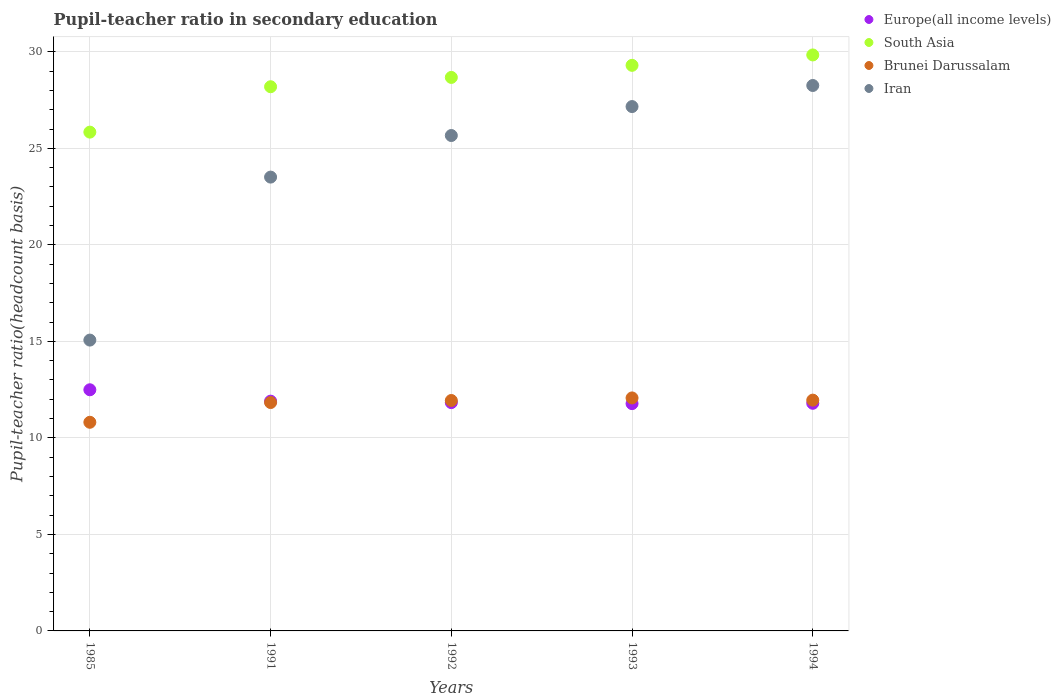What is the pupil-teacher ratio in secondary education in Brunei Darussalam in 1992?
Offer a terse response. 11.94. Across all years, what is the maximum pupil-teacher ratio in secondary education in South Asia?
Offer a very short reply. 29.84. Across all years, what is the minimum pupil-teacher ratio in secondary education in Brunei Darussalam?
Your answer should be compact. 10.81. What is the total pupil-teacher ratio in secondary education in Europe(all income levels) in the graph?
Give a very brief answer. 59.79. What is the difference between the pupil-teacher ratio in secondary education in South Asia in 1991 and that in 1994?
Provide a succinct answer. -1.65. What is the difference between the pupil-teacher ratio in secondary education in South Asia in 1985 and the pupil-teacher ratio in secondary education in Iran in 1993?
Provide a succinct answer. -1.32. What is the average pupil-teacher ratio in secondary education in Iran per year?
Provide a succinct answer. 23.93. In the year 1985, what is the difference between the pupil-teacher ratio in secondary education in Iran and pupil-teacher ratio in secondary education in Europe(all income levels)?
Your response must be concise. 2.57. What is the ratio of the pupil-teacher ratio in secondary education in Brunei Darussalam in 1991 to that in 1994?
Keep it short and to the point. 0.99. Is the pupil-teacher ratio in secondary education in Europe(all income levels) in 1985 less than that in 1992?
Give a very brief answer. No. Is the difference between the pupil-teacher ratio in secondary education in Iran in 1992 and 1993 greater than the difference between the pupil-teacher ratio in secondary education in Europe(all income levels) in 1992 and 1993?
Offer a very short reply. No. What is the difference between the highest and the second highest pupil-teacher ratio in secondary education in Brunei Darussalam?
Your response must be concise. 0.11. What is the difference between the highest and the lowest pupil-teacher ratio in secondary education in Europe(all income levels)?
Provide a succinct answer. 0.72. In how many years, is the pupil-teacher ratio in secondary education in Europe(all income levels) greater than the average pupil-teacher ratio in secondary education in Europe(all income levels) taken over all years?
Ensure brevity in your answer.  1. Is it the case that in every year, the sum of the pupil-teacher ratio in secondary education in Europe(all income levels) and pupil-teacher ratio in secondary education in Iran  is greater than the sum of pupil-teacher ratio in secondary education in South Asia and pupil-teacher ratio in secondary education in Brunei Darussalam?
Provide a short and direct response. Yes. Is it the case that in every year, the sum of the pupil-teacher ratio in secondary education in Europe(all income levels) and pupil-teacher ratio in secondary education in Iran  is greater than the pupil-teacher ratio in secondary education in South Asia?
Make the answer very short. Yes. Is the pupil-teacher ratio in secondary education in Iran strictly greater than the pupil-teacher ratio in secondary education in Brunei Darussalam over the years?
Make the answer very short. Yes. Is the pupil-teacher ratio in secondary education in Iran strictly less than the pupil-teacher ratio in secondary education in Brunei Darussalam over the years?
Your response must be concise. No. How many dotlines are there?
Your answer should be compact. 4. How many years are there in the graph?
Give a very brief answer. 5. Are the values on the major ticks of Y-axis written in scientific E-notation?
Give a very brief answer. No. Does the graph contain any zero values?
Offer a very short reply. No. Where does the legend appear in the graph?
Your answer should be very brief. Top right. What is the title of the graph?
Provide a short and direct response. Pupil-teacher ratio in secondary education. Does "St. Lucia" appear as one of the legend labels in the graph?
Your response must be concise. No. What is the label or title of the X-axis?
Your response must be concise. Years. What is the label or title of the Y-axis?
Provide a short and direct response. Pupil-teacher ratio(headcount basis). What is the Pupil-teacher ratio(headcount basis) of Europe(all income levels) in 1985?
Offer a terse response. 12.49. What is the Pupil-teacher ratio(headcount basis) in South Asia in 1985?
Give a very brief answer. 25.84. What is the Pupil-teacher ratio(headcount basis) in Brunei Darussalam in 1985?
Provide a succinct answer. 10.81. What is the Pupil-teacher ratio(headcount basis) of Iran in 1985?
Provide a short and direct response. 15.07. What is the Pupil-teacher ratio(headcount basis) in Europe(all income levels) in 1991?
Your response must be concise. 11.9. What is the Pupil-teacher ratio(headcount basis) in South Asia in 1991?
Make the answer very short. 28.19. What is the Pupil-teacher ratio(headcount basis) in Brunei Darussalam in 1991?
Your response must be concise. 11.83. What is the Pupil-teacher ratio(headcount basis) of Iran in 1991?
Make the answer very short. 23.51. What is the Pupil-teacher ratio(headcount basis) of Europe(all income levels) in 1992?
Your response must be concise. 11.83. What is the Pupil-teacher ratio(headcount basis) of South Asia in 1992?
Keep it short and to the point. 28.68. What is the Pupil-teacher ratio(headcount basis) in Brunei Darussalam in 1992?
Keep it short and to the point. 11.94. What is the Pupil-teacher ratio(headcount basis) of Iran in 1992?
Offer a terse response. 25.67. What is the Pupil-teacher ratio(headcount basis) of Europe(all income levels) in 1993?
Offer a terse response. 11.78. What is the Pupil-teacher ratio(headcount basis) in South Asia in 1993?
Provide a short and direct response. 29.3. What is the Pupil-teacher ratio(headcount basis) in Brunei Darussalam in 1993?
Offer a very short reply. 12.07. What is the Pupil-teacher ratio(headcount basis) in Iran in 1993?
Your answer should be very brief. 27.17. What is the Pupil-teacher ratio(headcount basis) of Europe(all income levels) in 1994?
Offer a very short reply. 11.79. What is the Pupil-teacher ratio(headcount basis) of South Asia in 1994?
Offer a terse response. 29.84. What is the Pupil-teacher ratio(headcount basis) of Brunei Darussalam in 1994?
Offer a terse response. 11.96. What is the Pupil-teacher ratio(headcount basis) in Iran in 1994?
Your response must be concise. 28.26. Across all years, what is the maximum Pupil-teacher ratio(headcount basis) of Europe(all income levels)?
Keep it short and to the point. 12.49. Across all years, what is the maximum Pupil-teacher ratio(headcount basis) of South Asia?
Your answer should be very brief. 29.84. Across all years, what is the maximum Pupil-teacher ratio(headcount basis) in Brunei Darussalam?
Your answer should be compact. 12.07. Across all years, what is the maximum Pupil-teacher ratio(headcount basis) in Iran?
Make the answer very short. 28.26. Across all years, what is the minimum Pupil-teacher ratio(headcount basis) of Europe(all income levels)?
Your response must be concise. 11.78. Across all years, what is the minimum Pupil-teacher ratio(headcount basis) in South Asia?
Provide a short and direct response. 25.84. Across all years, what is the minimum Pupil-teacher ratio(headcount basis) in Brunei Darussalam?
Make the answer very short. 10.81. Across all years, what is the minimum Pupil-teacher ratio(headcount basis) in Iran?
Make the answer very short. 15.07. What is the total Pupil-teacher ratio(headcount basis) in Europe(all income levels) in the graph?
Keep it short and to the point. 59.79. What is the total Pupil-teacher ratio(headcount basis) of South Asia in the graph?
Give a very brief answer. 141.85. What is the total Pupil-teacher ratio(headcount basis) of Brunei Darussalam in the graph?
Offer a very short reply. 58.61. What is the total Pupil-teacher ratio(headcount basis) in Iran in the graph?
Make the answer very short. 119.67. What is the difference between the Pupil-teacher ratio(headcount basis) in Europe(all income levels) in 1985 and that in 1991?
Offer a terse response. 0.59. What is the difference between the Pupil-teacher ratio(headcount basis) of South Asia in 1985 and that in 1991?
Provide a succinct answer. -2.35. What is the difference between the Pupil-teacher ratio(headcount basis) in Brunei Darussalam in 1985 and that in 1991?
Offer a very short reply. -1.02. What is the difference between the Pupil-teacher ratio(headcount basis) in Iran in 1985 and that in 1991?
Offer a very short reply. -8.44. What is the difference between the Pupil-teacher ratio(headcount basis) in Europe(all income levels) in 1985 and that in 1992?
Your answer should be very brief. 0.66. What is the difference between the Pupil-teacher ratio(headcount basis) in South Asia in 1985 and that in 1992?
Offer a terse response. -2.83. What is the difference between the Pupil-teacher ratio(headcount basis) of Brunei Darussalam in 1985 and that in 1992?
Ensure brevity in your answer.  -1.13. What is the difference between the Pupil-teacher ratio(headcount basis) in Iran in 1985 and that in 1992?
Your answer should be very brief. -10.6. What is the difference between the Pupil-teacher ratio(headcount basis) of Europe(all income levels) in 1985 and that in 1993?
Your answer should be very brief. 0.72. What is the difference between the Pupil-teacher ratio(headcount basis) of South Asia in 1985 and that in 1993?
Give a very brief answer. -3.46. What is the difference between the Pupil-teacher ratio(headcount basis) in Brunei Darussalam in 1985 and that in 1993?
Provide a succinct answer. -1.26. What is the difference between the Pupil-teacher ratio(headcount basis) of Iran in 1985 and that in 1993?
Offer a terse response. -12.1. What is the difference between the Pupil-teacher ratio(headcount basis) in Europe(all income levels) in 1985 and that in 1994?
Provide a succinct answer. 0.7. What is the difference between the Pupil-teacher ratio(headcount basis) of South Asia in 1985 and that in 1994?
Give a very brief answer. -4. What is the difference between the Pupil-teacher ratio(headcount basis) in Brunei Darussalam in 1985 and that in 1994?
Keep it short and to the point. -1.15. What is the difference between the Pupil-teacher ratio(headcount basis) in Iran in 1985 and that in 1994?
Provide a succinct answer. -13.19. What is the difference between the Pupil-teacher ratio(headcount basis) in Europe(all income levels) in 1991 and that in 1992?
Your answer should be compact. 0.07. What is the difference between the Pupil-teacher ratio(headcount basis) in South Asia in 1991 and that in 1992?
Give a very brief answer. -0.48. What is the difference between the Pupil-teacher ratio(headcount basis) of Brunei Darussalam in 1991 and that in 1992?
Ensure brevity in your answer.  -0.11. What is the difference between the Pupil-teacher ratio(headcount basis) in Iran in 1991 and that in 1992?
Offer a terse response. -2.15. What is the difference between the Pupil-teacher ratio(headcount basis) of Europe(all income levels) in 1991 and that in 1993?
Offer a terse response. 0.13. What is the difference between the Pupil-teacher ratio(headcount basis) of South Asia in 1991 and that in 1993?
Offer a very short reply. -1.11. What is the difference between the Pupil-teacher ratio(headcount basis) in Brunei Darussalam in 1991 and that in 1993?
Provide a succinct answer. -0.24. What is the difference between the Pupil-teacher ratio(headcount basis) of Iran in 1991 and that in 1993?
Give a very brief answer. -3.65. What is the difference between the Pupil-teacher ratio(headcount basis) of Europe(all income levels) in 1991 and that in 1994?
Offer a terse response. 0.11. What is the difference between the Pupil-teacher ratio(headcount basis) of South Asia in 1991 and that in 1994?
Ensure brevity in your answer.  -1.65. What is the difference between the Pupil-teacher ratio(headcount basis) of Brunei Darussalam in 1991 and that in 1994?
Keep it short and to the point. -0.12. What is the difference between the Pupil-teacher ratio(headcount basis) of Iran in 1991 and that in 1994?
Keep it short and to the point. -4.75. What is the difference between the Pupil-teacher ratio(headcount basis) of Europe(all income levels) in 1992 and that in 1993?
Make the answer very short. 0.05. What is the difference between the Pupil-teacher ratio(headcount basis) in South Asia in 1992 and that in 1993?
Your answer should be compact. -0.63. What is the difference between the Pupil-teacher ratio(headcount basis) of Brunei Darussalam in 1992 and that in 1993?
Your answer should be compact. -0.13. What is the difference between the Pupil-teacher ratio(headcount basis) of Iran in 1992 and that in 1993?
Your response must be concise. -1.5. What is the difference between the Pupil-teacher ratio(headcount basis) in Europe(all income levels) in 1992 and that in 1994?
Your answer should be compact. 0.04. What is the difference between the Pupil-teacher ratio(headcount basis) in South Asia in 1992 and that in 1994?
Ensure brevity in your answer.  -1.16. What is the difference between the Pupil-teacher ratio(headcount basis) in Brunei Darussalam in 1992 and that in 1994?
Your answer should be compact. -0.02. What is the difference between the Pupil-teacher ratio(headcount basis) in Iran in 1992 and that in 1994?
Offer a very short reply. -2.59. What is the difference between the Pupil-teacher ratio(headcount basis) of Europe(all income levels) in 1993 and that in 1994?
Give a very brief answer. -0.02. What is the difference between the Pupil-teacher ratio(headcount basis) in South Asia in 1993 and that in 1994?
Your answer should be very brief. -0.54. What is the difference between the Pupil-teacher ratio(headcount basis) of Brunei Darussalam in 1993 and that in 1994?
Your response must be concise. 0.11. What is the difference between the Pupil-teacher ratio(headcount basis) in Iran in 1993 and that in 1994?
Your answer should be compact. -1.09. What is the difference between the Pupil-teacher ratio(headcount basis) in Europe(all income levels) in 1985 and the Pupil-teacher ratio(headcount basis) in South Asia in 1991?
Offer a very short reply. -15.7. What is the difference between the Pupil-teacher ratio(headcount basis) of Europe(all income levels) in 1985 and the Pupil-teacher ratio(headcount basis) of Brunei Darussalam in 1991?
Give a very brief answer. 0.66. What is the difference between the Pupil-teacher ratio(headcount basis) in Europe(all income levels) in 1985 and the Pupil-teacher ratio(headcount basis) in Iran in 1991?
Offer a terse response. -11.02. What is the difference between the Pupil-teacher ratio(headcount basis) in South Asia in 1985 and the Pupil-teacher ratio(headcount basis) in Brunei Darussalam in 1991?
Keep it short and to the point. 14.01. What is the difference between the Pupil-teacher ratio(headcount basis) in South Asia in 1985 and the Pupil-teacher ratio(headcount basis) in Iran in 1991?
Make the answer very short. 2.33. What is the difference between the Pupil-teacher ratio(headcount basis) of Brunei Darussalam in 1985 and the Pupil-teacher ratio(headcount basis) of Iran in 1991?
Your answer should be very brief. -12.7. What is the difference between the Pupil-teacher ratio(headcount basis) of Europe(all income levels) in 1985 and the Pupil-teacher ratio(headcount basis) of South Asia in 1992?
Your answer should be compact. -16.18. What is the difference between the Pupil-teacher ratio(headcount basis) of Europe(all income levels) in 1985 and the Pupil-teacher ratio(headcount basis) of Brunei Darussalam in 1992?
Keep it short and to the point. 0.56. What is the difference between the Pupil-teacher ratio(headcount basis) of Europe(all income levels) in 1985 and the Pupil-teacher ratio(headcount basis) of Iran in 1992?
Provide a short and direct response. -13.17. What is the difference between the Pupil-teacher ratio(headcount basis) of South Asia in 1985 and the Pupil-teacher ratio(headcount basis) of Brunei Darussalam in 1992?
Your response must be concise. 13.9. What is the difference between the Pupil-teacher ratio(headcount basis) in South Asia in 1985 and the Pupil-teacher ratio(headcount basis) in Iran in 1992?
Make the answer very short. 0.18. What is the difference between the Pupil-teacher ratio(headcount basis) of Brunei Darussalam in 1985 and the Pupil-teacher ratio(headcount basis) of Iran in 1992?
Provide a succinct answer. -14.86. What is the difference between the Pupil-teacher ratio(headcount basis) of Europe(all income levels) in 1985 and the Pupil-teacher ratio(headcount basis) of South Asia in 1993?
Offer a very short reply. -16.81. What is the difference between the Pupil-teacher ratio(headcount basis) of Europe(all income levels) in 1985 and the Pupil-teacher ratio(headcount basis) of Brunei Darussalam in 1993?
Keep it short and to the point. 0.42. What is the difference between the Pupil-teacher ratio(headcount basis) of Europe(all income levels) in 1985 and the Pupil-teacher ratio(headcount basis) of Iran in 1993?
Provide a short and direct response. -14.67. What is the difference between the Pupil-teacher ratio(headcount basis) of South Asia in 1985 and the Pupil-teacher ratio(headcount basis) of Brunei Darussalam in 1993?
Make the answer very short. 13.77. What is the difference between the Pupil-teacher ratio(headcount basis) of South Asia in 1985 and the Pupil-teacher ratio(headcount basis) of Iran in 1993?
Your answer should be compact. -1.32. What is the difference between the Pupil-teacher ratio(headcount basis) in Brunei Darussalam in 1985 and the Pupil-teacher ratio(headcount basis) in Iran in 1993?
Provide a succinct answer. -16.36. What is the difference between the Pupil-teacher ratio(headcount basis) of Europe(all income levels) in 1985 and the Pupil-teacher ratio(headcount basis) of South Asia in 1994?
Offer a very short reply. -17.35. What is the difference between the Pupil-teacher ratio(headcount basis) of Europe(all income levels) in 1985 and the Pupil-teacher ratio(headcount basis) of Brunei Darussalam in 1994?
Provide a succinct answer. 0.54. What is the difference between the Pupil-teacher ratio(headcount basis) of Europe(all income levels) in 1985 and the Pupil-teacher ratio(headcount basis) of Iran in 1994?
Offer a very short reply. -15.76. What is the difference between the Pupil-teacher ratio(headcount basis) of South Asia in 1985 and the Pupil-teacher ratio(headcount basis) of Brunei Darussalam in 1994?
Ensure brevity in your answer.  13.88. What is the difference between the Pupil-teacher ratio(headcount basis) of South Asia in 1985 and the Pupil-teacher ratio(headcount basis) of Iran in 1994?
Your answer should be very brief. -2.42. What is the difference between the Pupil-teacher ratio(headcount basis) in Brunei Darussalam in 1985 and the Pupil-teacher ratio(headcount basis) in Iran in 1994?
Your response must be concise. -17.45. What is the difference between the Pupil-teacher ratio(headcount basis) of Europe(all income levels) in 1991 and the Pupil-teacher ratio(headcount basis) of South Asia in 1992?
Provide a succinct answer. -16.77. What is the difference between the Pupil-teacher ratio(headcount basis) in Europe(all income levels) in 1991 and the Pupil-teacher ratio(headcount basis) in Brunei Darussalam in 1992?
Offer a very short reply. -0.03. What is the difference between the Pupil-teacher ratio(headcount basis) in Europe(all income levels) in 1991 and the Pupil-teacher ratio(headcount basis) in Iran in 1992?
Offer a very short reply. -13.76. What is the difference between the Pupil-teacher ratio(headcount basis) in South Asia in 1991 and the Pupil-teacher ratio(headcount basis) in Brunei Darussalam in 1992?
Your answer should be compact. 16.26. What is the difference between the Pupil-teacher ratio(headcount basis) in South Asia in 1991 and the Pupil-teacher ratio(headcount basis) in Iran in 1992?
Provide a short and direct response. 2.53. What is the difference between the Pupil-teacher ratio(headcount basis) of Brunei Darussalam in 1991 and the Pupil-teacher ratio(headcount basis) of Iran in 1992?
Keep it short and to the point. -13.83. What is the difference between the Pupil-teacher ratio(headcount basis) in Europe(all income levels) in 1991 and the Pupil-teacher ratio(headcount basis) in South Asia in 1993?
Keep it short and to the point. -17.4. What is the difference between the Pupil-teacher ratio(headcount basis) in Europe(all income levels) in 1991 and the Pupil-teacher ratio(headcount basis) in Brunei Darussalam in 1993?
Give a very brief answer. -0.17. What is the difference between the Pupil-teacher ratio(headcount basis) in Europe(all income levels) in 1991 and the Pupil-teacher ratio(headcount basis) in Iran in 1993?
Keep it short and to the point. -15.26. What is the difference between the Pupil-teacher ratio(headcount basis) of South Asia in 1991 and the Pupil-teacher ratio(headcount basis) of Brunei Darussalam in 1993?
Keep it short and to the point. 16.12. What is the difference between the Pupil-teacher ratio(headcount basis) in South Asia in 1991 and the Pupil-teacher ratio(headcount basis) in Iran in 1993?
Ensure brevity in your answer.  1.03. What is the difference between the Pupil-teacher ratio(headcount basis) in Brunei Darussalam in 1991 and the Pupil-teacher ratio(headcount basis) in Iran in 1993?
Provide a short and direct response. -15.33. What is the difference between the Pupil-teacher ratio(headcount basis) in Europe(all income levels) in 1991 and the Pupil-teacher ratio(headcount basis) in South Asia in 1994?
Your answer should be compact. -17.94. What is the difference between the Pupil-teacher ratio(headcount basis) of Europe(all income levels) in 1991 and the Pupil-teacher ratio(headcount basis) of Brunei Darussalam in 1994?
Offer a very short reply. -0.05. What is the difference between the Pupil-teacher ratio(headcount basis) in Europe(all income levels) in 1991 and the Pupil-teacher ratio(headcount basis) in Iran in 1994?
Offer a very short reply. -16.35. What is the difference between the Pupil-teacher ratio(headcount basis) in South Asia in 1991 and the Pupil-teacher ratio(headcount basis) in Brunei Darussalam in 1994?
Keep it short and to the point. 16.24. What is the difference between the Pupil-teacher ratio(headcount basis) in South Asia in 1991 and the Pupil-teacher ratio(headcount basis) in Iran in 1994?
Keep it short and to the point. -0.06. What is the difference between the Pupil-teacher ratio(headcount basis) in Brunei Darussalam in 1991 and the Pupil-teacher ratio(headcount basis) in Iran in 1994?
Provide a short and direct response. -16.43. What is the difference between the Pupil-teacher ratio(headcount basis) of Europe(all income levels) in 1992 and the Pupil-teacher ratio(headcount basis) of South Asia in 1993?
Make the answer very short. -17.47. What is the difference between the Pupil-teacher ratio(headcount basis) of Europe(all income levels) in 1992 and the Pupil-teacher ratio(headcount basis) of Brunei Darussalam in 1993?
Provide a short and direct response. -0.24. What is the difference between the Pupil-teacher ratio(headcount basis) of Europe(all income levels) in 1992 and the Pupil-teacher ratio(headcount basis) of Iran in 1993?
Your answer should be compact. -15.34. What is the difference between the Pupil-teacher ratio(headcount basis) in South Asia in 1992 and the Pupil-teacher ratio(headcount basis) in Brunei Darussalam in 1993?
Your answer should be very brief. 16.61. What is the difference between the Pupil-teacher ratio(headcount basis) in South Asia in 1992 and the Pupil-teacher ratio(headcount basis) in Iran in 1993?
Make the answer very short. 1.51. What is the difference between the Pupil-teacher ratio(headcount basis) in Brunei Darussalam in 1992 and the Pupil-teacher ratio(headcount basis) in Iran in 1993?
Provide a short and direct response. -15.23. What is the difference between the Pupil-teacher ratio(headcount basis) in Europe(all income levels) in 1992 and the Pupil-teacher ratio(headcount basis) in South Asia in 1994?
Provide a succinct answer. -18.01. What is the difference between the Pupil-teacher ratio(headcount basis) in Europe(all income levels) in 1992 and the Pupil-teacher ratio(headcount basis) in Brunei Darussalam in 1994?
Your answer should be compact. -0.13. What is the difference between the Pupil-teacher ratio(headcount basis) in Europe(all income levels) in 1992 and the Pupil-teacher ratio(headcount basis) in Iran in 1994?
Your answer should be very brief. -16.43. What is the difference between the Pupil-teacher ratio(headcount basis) of South Asia in 1992 and the Pupil-teacher ratio(headcount basis) of Brunei Darussalam in 1994?
Give a very brief answer. 16.72. What is the difference between the Pupil-teacher ratio(headcount basis) in South Asia in 1992 and the Pupil-teacher ratio(headcount basis) in Iran in 1994?
Provide a succinct answer. 0.42. What is the difference between the Pupil-teacher ratio(headcount basis) in Brunei Darussalam in 1992 and the Pupil-teacher ratio(headcount basis) in Iran in 1994?
Provide a succinct answer. -16.32. What is the difference between the Pupil-teacher ratio(headcount basis) of Europe(all income levels) in 1993 and the Pupil-teacher ratio(headcount basis) of South Asia in 1994?
Offer a very short reply. -18.06. What is the difference between the Pupil-teacher ratio(headcount basis) of Europe(all income levels) in 1993 and the Pupil-teacher ratio(headcount basis) of Brunei Darussalam in 1994?
Provide a succinct answer. -0.18. What is the difference between the Pupil-teacher ratio(headcount basis) in Europe(all income levels) in 1993 and the Pupil-teacher ratio(headcount basis) in Iran in 1994?
Your answer should be compact. -16.48. What is the difference between the Pupil-teacher ratio(headcount basis) of South Asia in 1993 and the Pupil-teacher ratio(headcount basis) of Brunei Darussalam in 1994?
Offer a terse response. 17.35. What is the difference between the Pupil-teacher ratio(headcount basis) of South Asia in 1993 and the Pupil-teacher ratio(headcount basis) of Iran in 1994?
Provide a succinct answer. 1.04. What is the difference between the Pupil-teacher ratio(headcount basis) in Brunei Darussalam in 1993 and the Pupil-teacher ratio(headcount basis) in Iran in 1994?
Provide a short and direct response. -16.19. What is the average Pupil-teacher ratio(headcount basis) in Europe(all income levels) per year?
Provide a succinct answer. 11.96. What is the average Pupil-teacher ratio(headcount basis) in South Asia per year?
Provide a succinct answer. 28.37. What is the average Pupil-teacher ratio(headcount basis) of Brunei Darussalam per year?
Keep it short and to the point. 11.72. What is the average Pupil-teacher ratio(headcount basis) in Iran per year?
Your answer should be very brief. 23.93. In the year 1985, what is the difference between the Pupil-teacher ratio(headcount basis) of Europe(all income levels) and Pupil-teacher ratio(headcount basis) of South Asia?
Provide a short and direct response. -13.35. In the year 1985, what is the difference between the Pupil-teacher ratio(headcount basis) in Europe(all income levels) and Pupil-teacher ratio(headcount basis) in Brunei Darussalam?
Keep it short and to the point. 1.68. In the year 1985, what is the difference between the Pupil-teacher ratio(headcount basis) of Europe(all income levels) and Pupil-teacher ratio(headcount basis) of Iran?
Make the answer very short. -2.57. In the year 1985, what is the difference between the Pupil-teacher ratio(headcount basis) in South Asia and Pupil-teacher ratio(headcount basis) in Brunei Darussalam?
Your answer should be compact. 15.03. In the year 1985, what is the difference between the Pupil-teacher ratio(headcount basis) in South Asia and Pupil-teacher ratio(headcount basis) in Iran?
Your response must be concise. 10.77. In the year 1985, what is the difference between the Pupil-teacher ratio(headcount basis) in Brunei Darussalam and Pupil-teacher ratio(headcount basis) in Iran?
Offer a terse response. -4.26. In the year 1991, what is the difference between the Pupil-teacher ratio(headcount basis) of Europe(all income levels) and Pupil-teacher ratio(headcount basis) of South Asia?
Give a very brief answer. -16.29. In the year 1991, what is the difference between the Pupil-teacher ratio(headcount basis) in Europe(all income levels) and Pupil-teacher ratio(headcount basis) in Brunei Darussalam?
Provide a short and direct response. 0.07. In the year 1991, what is the difference between the Pupil-teacher ratio(headcount basis) of Europe(all income levels) and Pupil-teacher ratio(headcount basis) of Iran?
Give a very brief answer. -11.61. In the year 1991, what is the difference between the Pupil-teacher ratio(headcount basis) in South Asia and Pupil-teacher ratio(headcount basis) in Brunei Darussalam?
Offer a very short reply. 16.36. In the year 1991, what is the difference between the Pupil-teacher ratio(headcount basis) in South Asia and Pupil-teacher ratio(headcount basis) in Iran?
Offer a terse response. 4.68. In the year 1991, what is the difference between the Pupil-teacher ratio(headcount basis) in Brunei Darussalam and Pupil-teacher ratio(headcount basis) in Iran?
Your answer should be very brief. -11.68. In the year 1992, what is the difference between the Pupil-teacher ratio(headcount basis) in Europe(all income levels) and Pupil-teacher ratio(headcount basis) in South Asia?
Offer a very short reply. -16.85. In the year 1992, what is the difference between the Pupil-teacher ratio(headcount basis) of Europe(all income levels) and Pupil-teacher ratio(headcount basis) of Brunei Darussalam?
Give a very brief answer. -0.11. In the year 1992, what is the difference between the Pupil-teacher ratio(headcount basis) in Europe(all income levels) and Pupil-teacher ratio(headcount basis) in Iran?
Keep it short and to the point. -13.84. In the year 1992, what is the difference between the Pupil-teacher ratio(headcount basis) of South Asia and Pupil-teacher ratio(headcount basis) of Brunei Darussalam?
Offer a terse response. 16.74. In the year 1992, what is the difference between the Pupil-teacher ratio(headcount basis) in South Asia and Pupil-teacher ratio(headcount basis) in Iran?
Give a very brief answer. 3.01. In the year 1992, what is the difference between the Pupil-teacher ratio(headcount basis) in Brunei Darussalam and Pupil-teacher ratio(headcount basis) in Iran?
Offer a terse response. -13.73. In the year 1993, what is the difference between the Pupil-teacher ratio(headcount basis) of Europe(all income levels) and Pupil-teacher ratio(headcount basis) of South Asia?
Your response must be concise. -17.53. In the year 1993, what is the difference between the Pupil-teacher ratio(headcount basis) in Europe(all income levels) and Pupil-teacher ratio(headcount basis) in Brunei Darussalam?
Your answer should be very brief. -0.3. In the year 1993, what is the difference between the Pupil-teacher ratio(headcount basis) in Europe(all income levels) and Pupil-teacher ratio(headcount basis) in Iran?
Offer a very short reply. -15.39. In the year 1993, what is the difference between the Pupil-teacher ratio(headcount basis) of South Asia and Pupil-teacher ratio(headcount basis) of Brunei Darussalam?
Offer a very short reply. 17.23. In the year 1993, what is the difference between the Pupil-teacher ratio(headcount basis) in South Asia and Pupil-teacher ratio(headcount basis) in Iran?
Give a very brief answer. 2.14. In the year 1993, what is the difference between the Pupil-teacher ratio(headcount basis) in Brunei Darussalam and Pupil-teacher ratio(headcount basis) in Iran?
Your answer should be compact. -15.09. In the year 1994, what is the difference between the Pupil-teacher ratio(headcount basis) in Europe(all income levels) and Pupil-teacher ratio(headcount basis) in South Asia?
Your answer should be compact. -18.05. In the year 1994, what is the difference between the Pupil-teacher ratio(headcount basis) of Europe(all income levels) and Pupil-teacher ratio(headcount basis) of Brunei Darussalam?
Provide a succinct answer. -0.16. In the year 1994, what is the difference between the Pupil-teacher ratio(headcount basis) of Europe(all income levels) and Pupil-teacher ratio(headcount basis) of Iran?
Your answer should be very brief. -16.46. In the year 1994, what is the difference between the Pupil-teacher ratio(headcount basis) of South Asia and Pupil-teacher ratio(headcount basis) of Brunei Darussalam?
Give a very brief answer. 17.88. In the year 1994, what is the difference between the Pupil-teacher ratio(headcount basis) in South Asia and Pupil-teacher ratio(headcount basis) in Iran?
Provide a short and direct response. 1.58. In the year 1994, what is the difference between the Pupil-teacher ratio(headcount basis) of Brunei Darussalam and Pupil-teacher ratio(headcount basis) of Iran?
Provide a succinct answer. -16.3. What is the ratio of the Pupil-teacher ratio(headcount basis) of Europe(all income levels) in 1985 to that in 1991?
Your answer should be very brief. 1.05. What is the ratio of the Pupil-teacher ratio(headcount basis) in South Asia in 1985 to that in 1991?
Your answer should be very brief. 0.92. What is the ratio of the Pupil-teacher ratio(headcount basis) of Brunei Darussalam in 1985 to that in 1991?
Provide a succinct answer. 0.91. What is the ratio of the Pupil-teacher ratio(headcount basis) in Iran in 1985 to that in 1991?
Provide a short and direct response. 0.64. What is the ratio of the Pupil-teacher ratio(headcount basis) of Europe(all income levels) in 1985 to that in 1992?
Your answer should be compact. 1.06. What is the ratio of the Pupil-teacher ratio(headcount basis) of South Asia in 1985 to that in 1992?
Ensure brevity in your answer.  0.9. What is the ratio of the Pupil-teacher ratio(headcount basis) of Brunei Darussalam in 1985 to that in 1992?
Your answer should be very brief. 0.91. What is the ratio of the Pupil-teacher ratio(headcount basis) of Iran in 1985 to that in 1992?
Keep it short and to the point. 0.59. What is the ratio of the Pupil-teacher ratio(headcount basis) in Europe(all income levels) in 1985 to that in 1993?
Your response must be concise. 1.06. What is the ratio of the Pupil-teacher ratio(headcount basis) of South Asia in 1985 to that in 1993?
Ensure brevity in your answer.  0.88. What is the ratio of the Pupil-teacher ratio(headcount basis) of Brunei Darussalam in 1985 to that in 1993?
Provide a short and direct response. 0.9. What is the ratio of the Pupil-teacher ratio(headcount basis) in Iran in 1985 to that in 1993?
Keep it short and to the point. 0.55. What is the ratio of the Pupil-teacher ratio(headcount basis) of Europe(all income levels) in 1985 to that in 1994?
Your answer should be compact. 1.06. What is the ratio of the Pupil-teacher ratio(headcount basis) of South Asia in 1985 to that in 1994?
Make the answer very short. 0.87. What is the ratio of the Pupil-teacher ratio(headcount basis) in Brunei Darussalam in 1985 to that in 1994?
Your answer should be compact. 0.9. What is the ratio of the Pupil-teacher ratio(headcount basis) in Iran in 1985 to that in 1994?
Offer a terse response. 0.53. What is the ratio of the Pupil-teacher ratio(headcount basis) in Europe(all income levels) in 1991 to that in 1992?
Ensure brevity in your answer.  1.01. What is the ratio of the Pupil-teacher ratio(headcount basis) in South Asia in 1991 to that in 1992?
Make the answer very short. 0.98. What is the ratio of the Pupil-teacher ratio(headcount basis) in Brunei Darussalam in 1991 to that in 1992?
Give a very brief answer. 0.99. What is the ratio of the Pupil-teacher ratio(headcount basis) of Iran in 1991 to that in 1992?
Your answer should be very brief. 0.92. What is the ratio of the Pupil-teacher ratio(headcount basis) in Europe(all income levels) in 1991 to that in 1993?
Give a very brief answer. 1.01. What is the ratio of the Pupil-teacher ratio(headcount basis) in South Asia in 1991 to that in 1993?
Make the answer very short. 0.96. What is the ratio of the Pupil-teacher ratio(headcount basis) in Brunei Darussalam in 1991 to that in 1993?
Ensure brevity in your answer.  0.98. What is the ratio of the Pupil-teacher ratio(headcount basis) of Iran in 1991 to that in 1993?
Your answer should be compact. 0.87. What is the ratio of the Pupil-teacher ratio(headcount basis) of Europe(all income levels) in 1991 to that in 1994?
Offer a very short reply. 1.01. What is the ratio of the Pupil-teacher ratio(headcount basis) in South Asia in 1991 to that in 1994?
Make the answer very short. 0.94. What is the ratio of the Pupil-teacher ratio(headcount basis) of Iran in 1991 to that in 1994?
Your answer should be very brief. 0.83. What is the ratio of the Pupil-teacher ratio(headcount basis) in South Asia in 1992 to that in 1993?
Offer a very short reply. 0.98. What is the ratio of the Pupil-teacher ratio(headcount basis) in Brunei Darussalam in 1992 to that in 1993?
Provide a succinct answer. 0.99. What is the ratio of the Pupil-teacher ratio(headcount basis) in Iran in 1992 to that in 1993?
Your response must be concise. 0.94. What is the ratio of the Pupil-teacher ratio(headcount basis) of Europe(all income levels) in 1992 to that in 1994?
Ensure brevity in your answer.  1. What is the ratio of the Pupil-teacher ratio(headcount basis) in South Asia in 1992 to that in 1994?
Your answer should be very brief. 0.96. What is the ratio of the Pupil-teacher ratio(headcount basis) in Brunei Darussalam in 1992 to that in 1994?
Your answer should be very brief. 1. What is the ratio of the Pupil-teacher ratio(headcount basis) in Iran in 1992 to that in 1994?
Offer a very short reply. 0.91. What is the ratio of the Pupil-teacher ratio(headcount basis) of Europe(all income levels) in 1993 to that in 1994?
Ensure brevity in your answer.  1. What is the ratio of the Pupil-teacher ratio(headcount basis) of South Asia in 1993 to that in 1994?
Offer a very short reply. 0.98. What is the ratio of the Pupil-teacher ratio(headcount basis) of Brunei Darussalam in 1993 to that in 1994?
Your response must be concise. 1.01. What is the ratio of the Pupil-teacher ratio(headcount basis) of Iran in 1993 to that in 1994?
Give a very brief answer. 0.96. What is the difference between the highest and the second highest Pupil-teacher ratio(headcount basis) in Europe(all income levels)?
Your response must be concise. 0.59. What is the difference between the highest and the second highest Pupil-teacher ratio(headcount basis) of South Asia?
Provide a succinct answer. 0.54. What is the difference between the highest and the second highest Pupil-teacher ratio(headcount basis) of Brunei Darussalam?
Make the answer very short. 0.11. What is the difference between the highest and the second highest Pupil-teacher ratio(headcount basis) in Iran?
Ensure brevity in your answer.  1.09. What is the difference between the highest and the lowest Pupil-teacher ratio(headcount basis) in Europe(all income levels)?
Offer a terse response. 0.72. What is the difference between the highest and the lowest Pupil-teacher ratio(headcount basis) in South Asia?
Provide a short and direct response. 4. What is the difference between the highest and the lowest Pupil-teacher ratio(headcount basis) in Brunei Darussalam?
Offer a very short reply. 1.26. What is the difference between the highest and the lowest Pupil-teacher ratio(headcount basis) in Iran?
Provide a succinct answer. 13.19. 